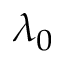Convert formula to latex. <formula><loc_0><loc_0><loc_500><loc_500>\lambda _ { 0 }</formula> 